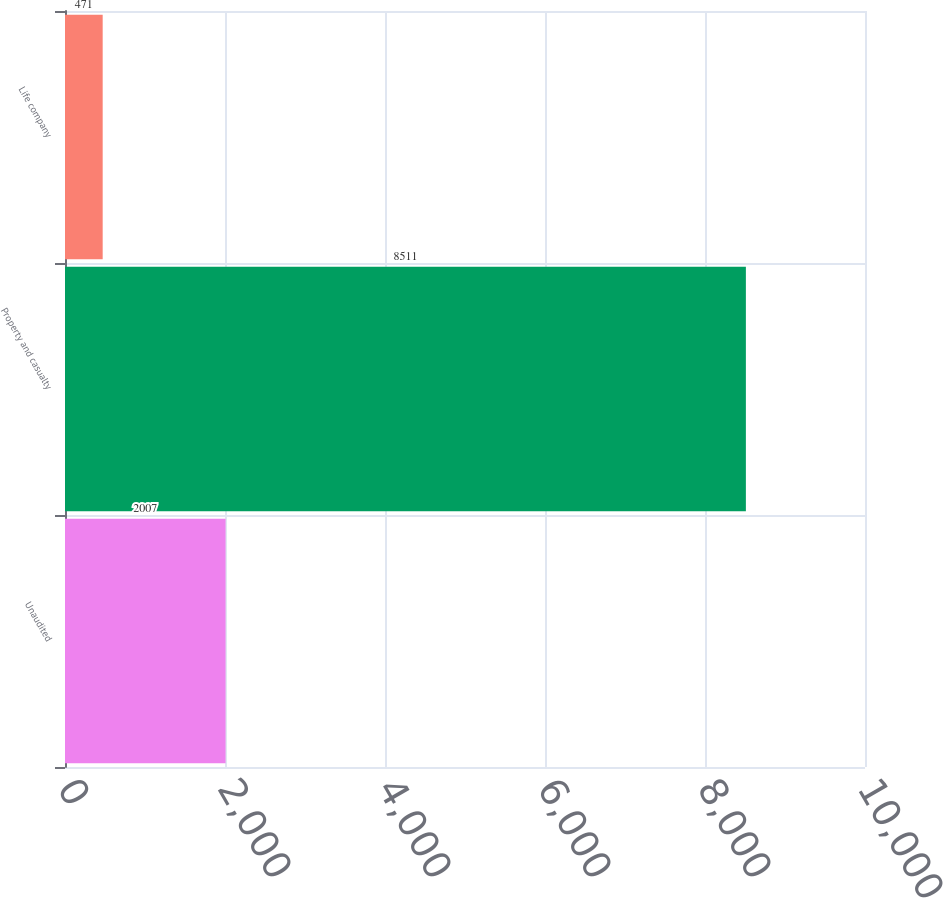Convert chart to OTSL. <chart><loc_0><loc_0><loc_500><loc_500><bar_chart><fcel>Unaudited<fcel>Property and casualty<fcel>Life company<nl><fcel>2007<fcel>8511<fcel>471<nl></chart> 